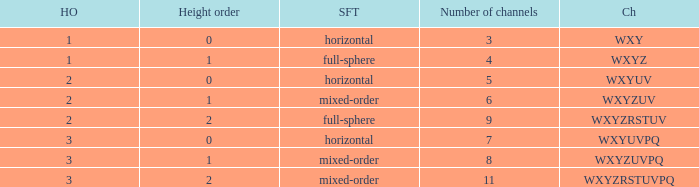If the channels is wxyzrstuvpq, what is the horizontal order? 3.0. 